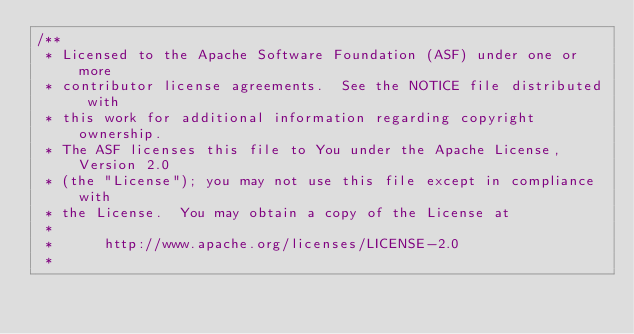<code> <loc_0><loc_0><loc_500><loc_500><_Java_>/**
 * Licensed to the Apache Software Foundation (ASF) under one or more
 * contributor license agreements.  See the NOTICE file distributed with
 * this work for additional information regarding copyright ownership.
 * The ASF licenses this file to You under the Apache License, Version 2.0
 * (the "License"); you may not use this file except in compliance with
 * the License.  You may obtain a copy of the License at
 *
 *      http://www.apache.org/licenses/LICENSE-2.0
 *</code> 